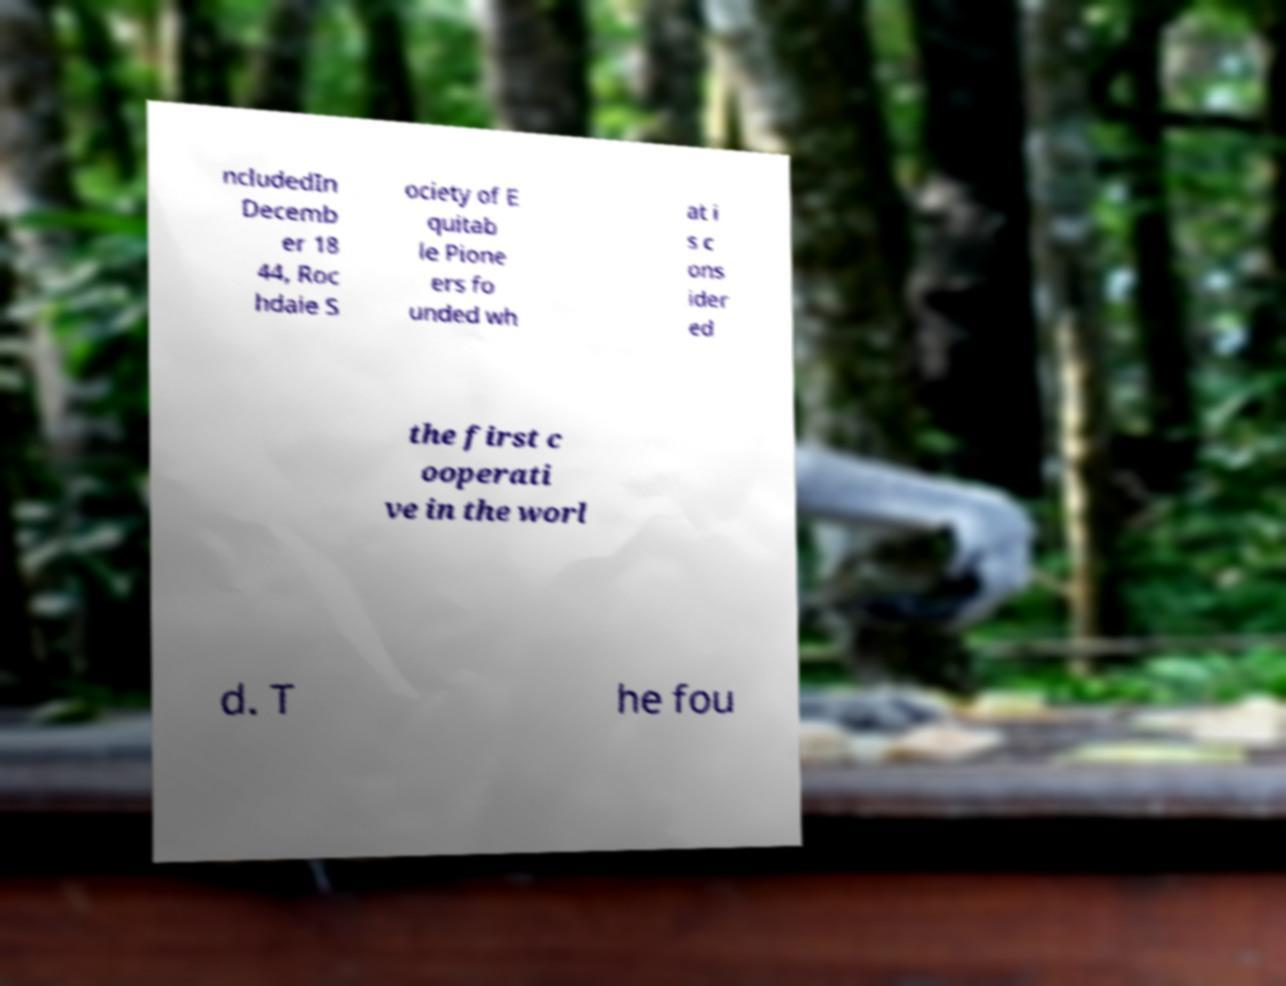Please read and relay the text visible in this image. What does it say? ncludedIn Decemb er 18 44, Roc hdale S ociety of E quitab le Pione ers fo unded wh at i s c ons ider ed the first c ooperati ve in the worl d. T he fou 